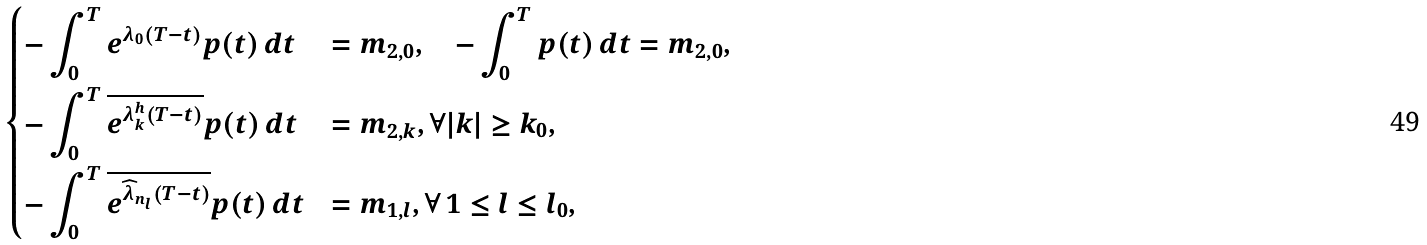Convert formula to latex. <formula><loc_0><loc_0><loc_500><loc_500>\begin{dcases} - \int _ { 0 } ^ { T } e ^ { \lambda _ { 0 } ( T - t ) } p ( t ) \, d t & = m _ { 2 , 0 } , \quad - \int _ { 0 } ^ { T } p ( t ) \, d t = m _ { 2 , 0 } , \\ - \int _ { 0 } ^ { T } \overline { e ^ { \lambda ^ { h } _ { k } ( T - t ) } } p ( t ) \, d t & = m _ { 2 , k } , \forall | k | \geq k _ { 0 } , \\ - \int _ { 0 } ^ { T } \overline { e ^ { \widehat { \lambda } _ { n _ { l } } ( T - t ) } } p ( t ) \, d t & = m _ { 1 , l } , \forall \, 1 \leq l \leq l _ { 0 } , \end{dcases}</formula> 